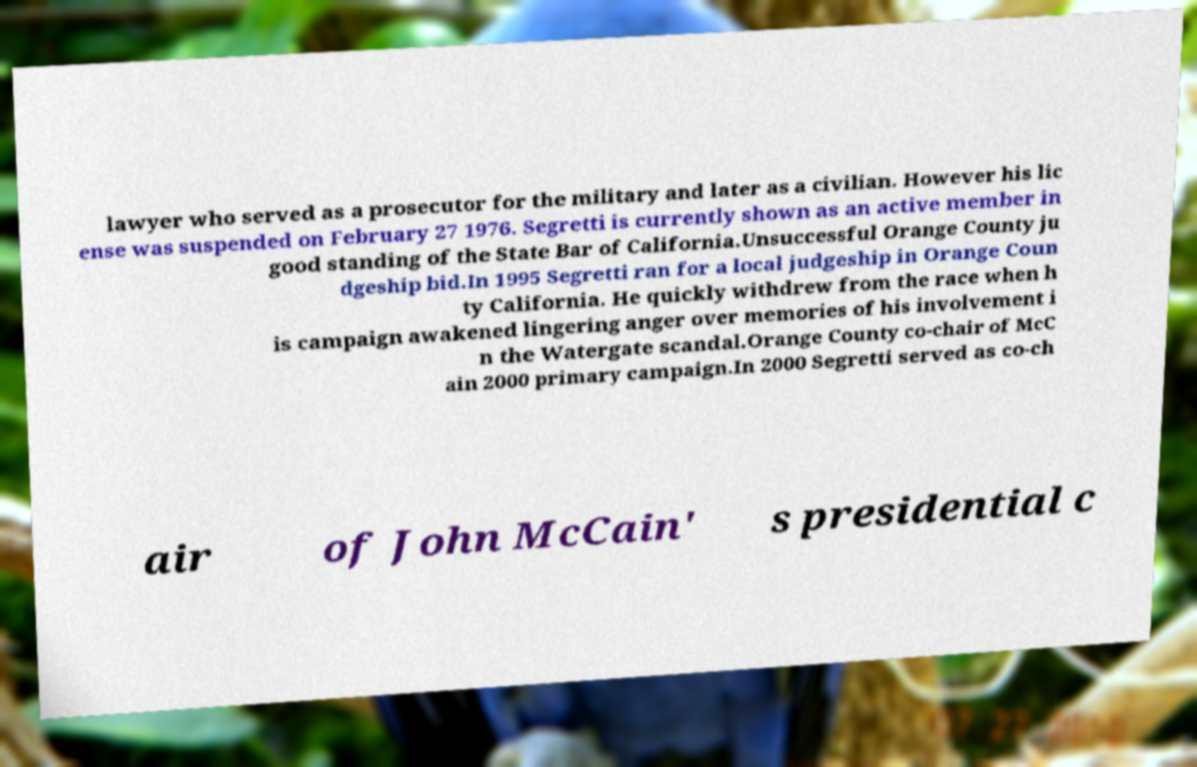Could you assist in decoding the text presented in this image and type it out clearly? lawyer who served as a prosecutor for the military and later as a civilian. However his lic ense was suspended on February 27 1976. Segretti is currently shown as an active member in good standing of the State Bar of California.Unsuccessful Orange County ju dgeship bid.In 1995 Segretti ran for a local judgeship in Orange Coun ty California. He quickly withdrew from the race when h is campaign awakened lingering anger over memories of his involvement i n the Watergate scandal.Orange County co-chair of McC ain 2000 primary campaign.In 2000 Segretti served as co-ch air of John McCain' s presidential c 